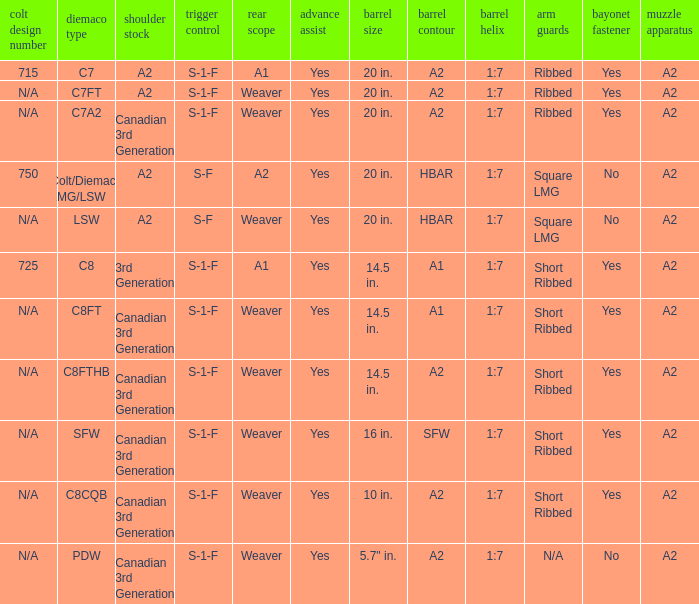Which hand protectors have an a2 barrel contour and a weaver rear sight? Ribbed, Ribbed, Short Ribbed, Short Ribbed, N/A. 